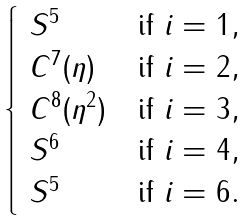Convert formula to latex. <formula><loc_0><loc_0><loc_500><loc_500>\begin{cases} \ S ^ { 5 } & \text {if } i = 1 , \\ \ C ^ { 7 } ( \eta ) & \text {if } i = 2 , \\ \ C ^ { 8 } ( \eta ^ { 2 } ) & \text {if } i = 3 , \\ \ S ^ { 6 } & \text {if } i = 4 , \\ \ S ^ { 5 } & \text {if } i = 6 . \end{cases}</formula> 